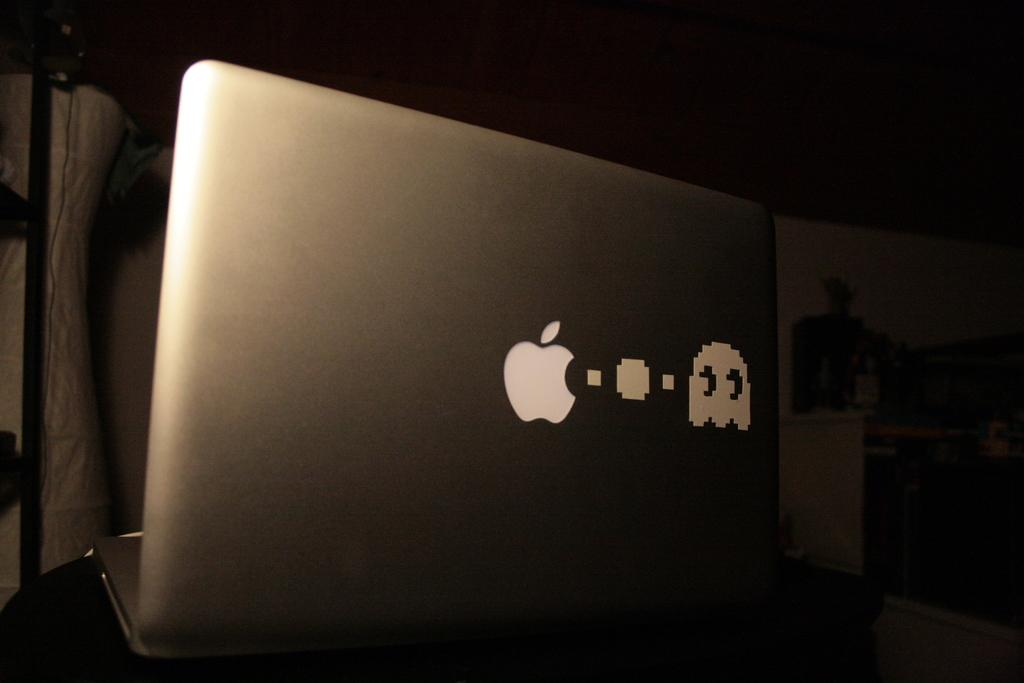What electronic device is visible in the image? There is a laptop in the image. What other objects are near the laptop? There are objects beside the laptop. What can be seen in the background of the image? There is a wall visible in the image. How many cakes are balanced on the laptop in the image? There are no cakes present in the image, and the laptop is not being used to balance anything. 